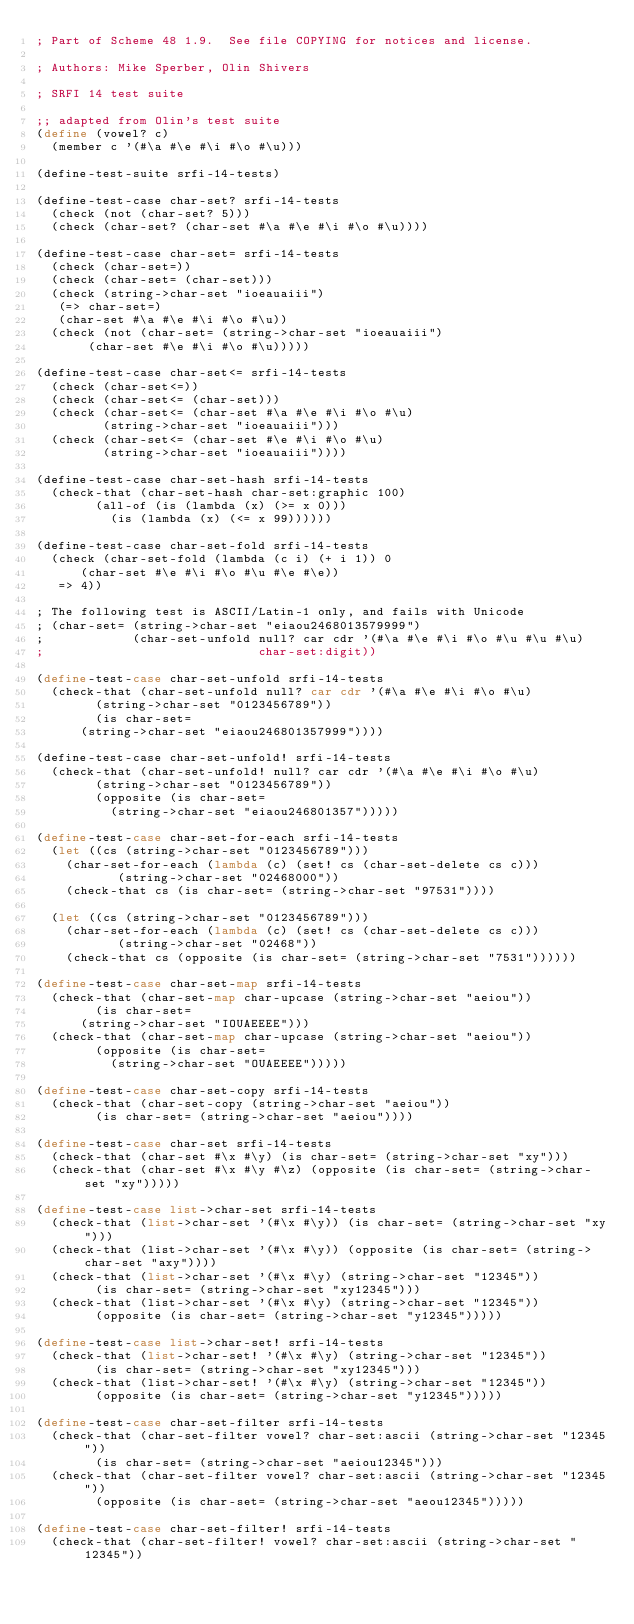Convert code to text. <code><loc_0><loc_0><loc_500><loc_500><_Scheme_>; Part of Scheme 48 1.9.  See file COPYING for notices and license.

; Authors: Mike Sperber, Olin Shivers

; SRFI 14 test suite

;; adapted from Olin's test suite
(define (vowel? c)
  (member c '(#\a #\e #\i #\o #\u)))

(define-test-suite srfi-14-tests)

(define-test-case char-set? srfi-14-tests
  (check (not (char-set? 5)))
  (check (char-set? (char-set #\a #\e #\i #\o #\u))))

(define-test-case char-set= srfi-14-tests
  (check (char-set=))
  (check (char-set= (char-set)))
  (check (string->char-set "ioeauaiii")
	 (=> char-set=)
	 (char-set #\a #\e #\i #\o #\u))
  (check (not (char-set= (string->char-set "ioeauaiii")
			 (char-set #\e #\i #\o #\u)))))

(define-test-case char-set<= srfi-14-tests
  (check (char-set<=))
  (check (char-set<= (char-set)))
  (check (char-set<= (char-set #\a #\e #\i #\o #\u)
		     (string->char-set "ioeauaiii")))
  (check (char-set<= (char-set #\e #\i #\o #\u)
		     (string->char-set "ioeauaiii"))))

(define-test-case char-set-hash srfi-14-tests
  (check-that (char-set-hash char-set:graphic 100)
	      (all-of (is (lambda (x) (>= x 0)))
		      (is (lambda (x) (<= x 99))))))

(define-test-case char-set-fold srfi-14-tests
  (check (char-set-fold (lambda (c i) (+ i 1)) 0
			(char-set #\e #\i #\o #\u #\e #\e))
	 => 4))

; The following test is ASCII/Latin-1 only, and fails with Unicode
; (char-set= (string->char-set "eiaou2468013579999")
;            (char-set-unfold null? car cdr '(#\a #\e #\i #\o #\u #\u #\u)
;                             char-set:digit))

(define-test-case char-set-unfold srfi-14-tests
  (check-that (char-set-unfold null? car cdr '(#\a #\e #\i #\o #\u)
			  (string->char-set "0123456789"))
	      (is char-set=
		  (string->char-set "eiaou246801357999"))))

(define-test-case char-set-unfold! srfi-14-tests
  (check-that (char-set-unfold! null? car cdr '(#\a #\e #\i #\o #\u)
				(string->char-set "0123456789"))
	      (opposite (is char-set= 
			    (string->char-set "eiaou246801357")))))

(define-test-case char-set-for-each srfi-14-tests
  (let ((cs (string->char-set "0123456789")))
    (char-set-for-each (lambda (c) (set! cs (char-set-delete cs c)))
		       (string->char-set "02468000"))
    (check-that cs (is char-set= (string->char-set "97531"))))

  (let ((cs (string->char-set "0123456789")))
    (char-set-for-each (lambda (c) (set! cs (char-set-delete cs c)))
		       (string->char-set "02468"))
    (check-that cs (opposite (is char-set= (string->char-set "7531"))))))

(define-test-case char-set-map srfi-14-tests
  (check-that (char-set-map char-upcase (string->char-set "aeiou"))
	      (is char-set=
		  (string->char-set "IOUAEEEE")))
  (check-that (char-set-map char-upcase (string->char-set "aeiou"))
	      (opposite (is char-set= 
			    (string->char-set "OUAEEEE")))))

(define-test-case char-set-copy srfi-14-tests
  (check-that (char-set-copy (string->char-set "aeiou"))
	      (is char-set= (string->char-set "aeiou"))))

(define-test-case char-set srfi-14-tests
  (check-that (char-set #\x #\y) (is char-set= (string->char-set "xy")))
  (check-that (char-set #\x #\y #\z) (opposite (is char-set= (string->char-set "xy")))))

(define-test-case list->char-set srfi-14-tests
  (check-that (list->char-set '(#\x #\y)) (is char-set= (string->char-set "xy")))
  (check-that (list->char-set '(#\x #\y)) (opposite (is char-set= (string->char-set "axy"))))
  (check-that (list->char-set '(#\x #\y) (string->char-set "12345"))
	      (is char-set= (string->char-set "xy12345")))
  (check-that (list->char-set '(#\x #\y) (string->char-set "12345"))
	      (opposite (is char-set= (string->char-set "y12345")))))

(define-test-case list->char-set! srfi-14-tests
  (check-that (list->char-set! '(#\x #\y) (string->char-set "12345"))
	      (is char-set= (string->char-set "xy12345")))
  (check-that (list->char-set! '(#\x #\y) (string->char-set "12345"))
	      (opposite (is char-set= (string->char-set "y12345")))))

(define-test-case char-set-filter srfi-14-tests
  (check-that (char-set-filter vowel? char-set:ascii (string->char-set "12345"))
	      (is char-set= (string->char-set "aeiou12345")))
  (check-that (char-set-filter vowel? char-set:ascii (string->char-set "12345"))
	      (opposite (is char-set= (string->char-set "aeou12345")))))

(define-test-case char-set-filter! srfi-14-tests
  (check-that (char-set-filter! vowel? char-set:ascii (string->char-set "12345"))</code> 